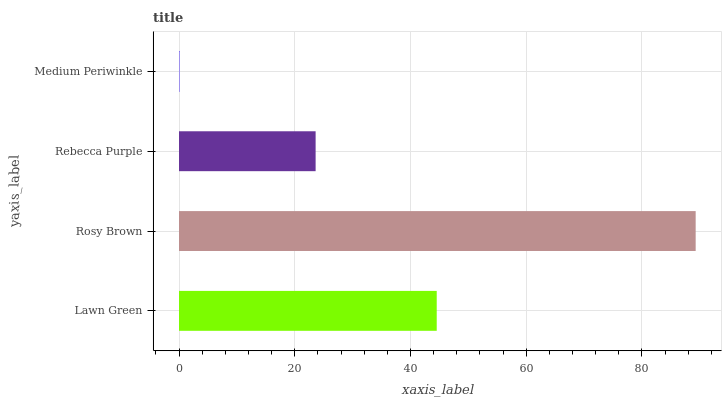Is Medium Periwinkle the minimum?
Answer yes or no. Yes. Is Rosy Brown the maximum?
Answer yes or no. Yes. Is Rebecca Purple the minimum?
Answer yes or no. No. Is Rebecca Purple the maximum?
Answer yes or no. No. Is Rosy Brown greater than Rebecca Purple?
Answer yes or no. Yes. Is Rebecca Purple less than Rosy Brown?
Answer yes or no. Yes. Is Rebecca Purple greater than Rosy Brown?
Answer yes or no. No. Is Rosy Brown less than Rebecca Purple?
Answer yes or no. No. Is Lawn Green the high median?
Answer yes or no. Yes. Is Rebecca Purple the low median?
Answer yes or no. Yes. Is Medium Periwinkle the high median?
Answer yes or no. No. Is Medium Periwinkle the low median?
Answer yes or no. No. 